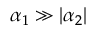Convert formula to latex. <formula><loc_0><loc_0><loc_500><loc_500>\alpha _ { 1 } \gg | \alpha _ { 2 } |</formula> 